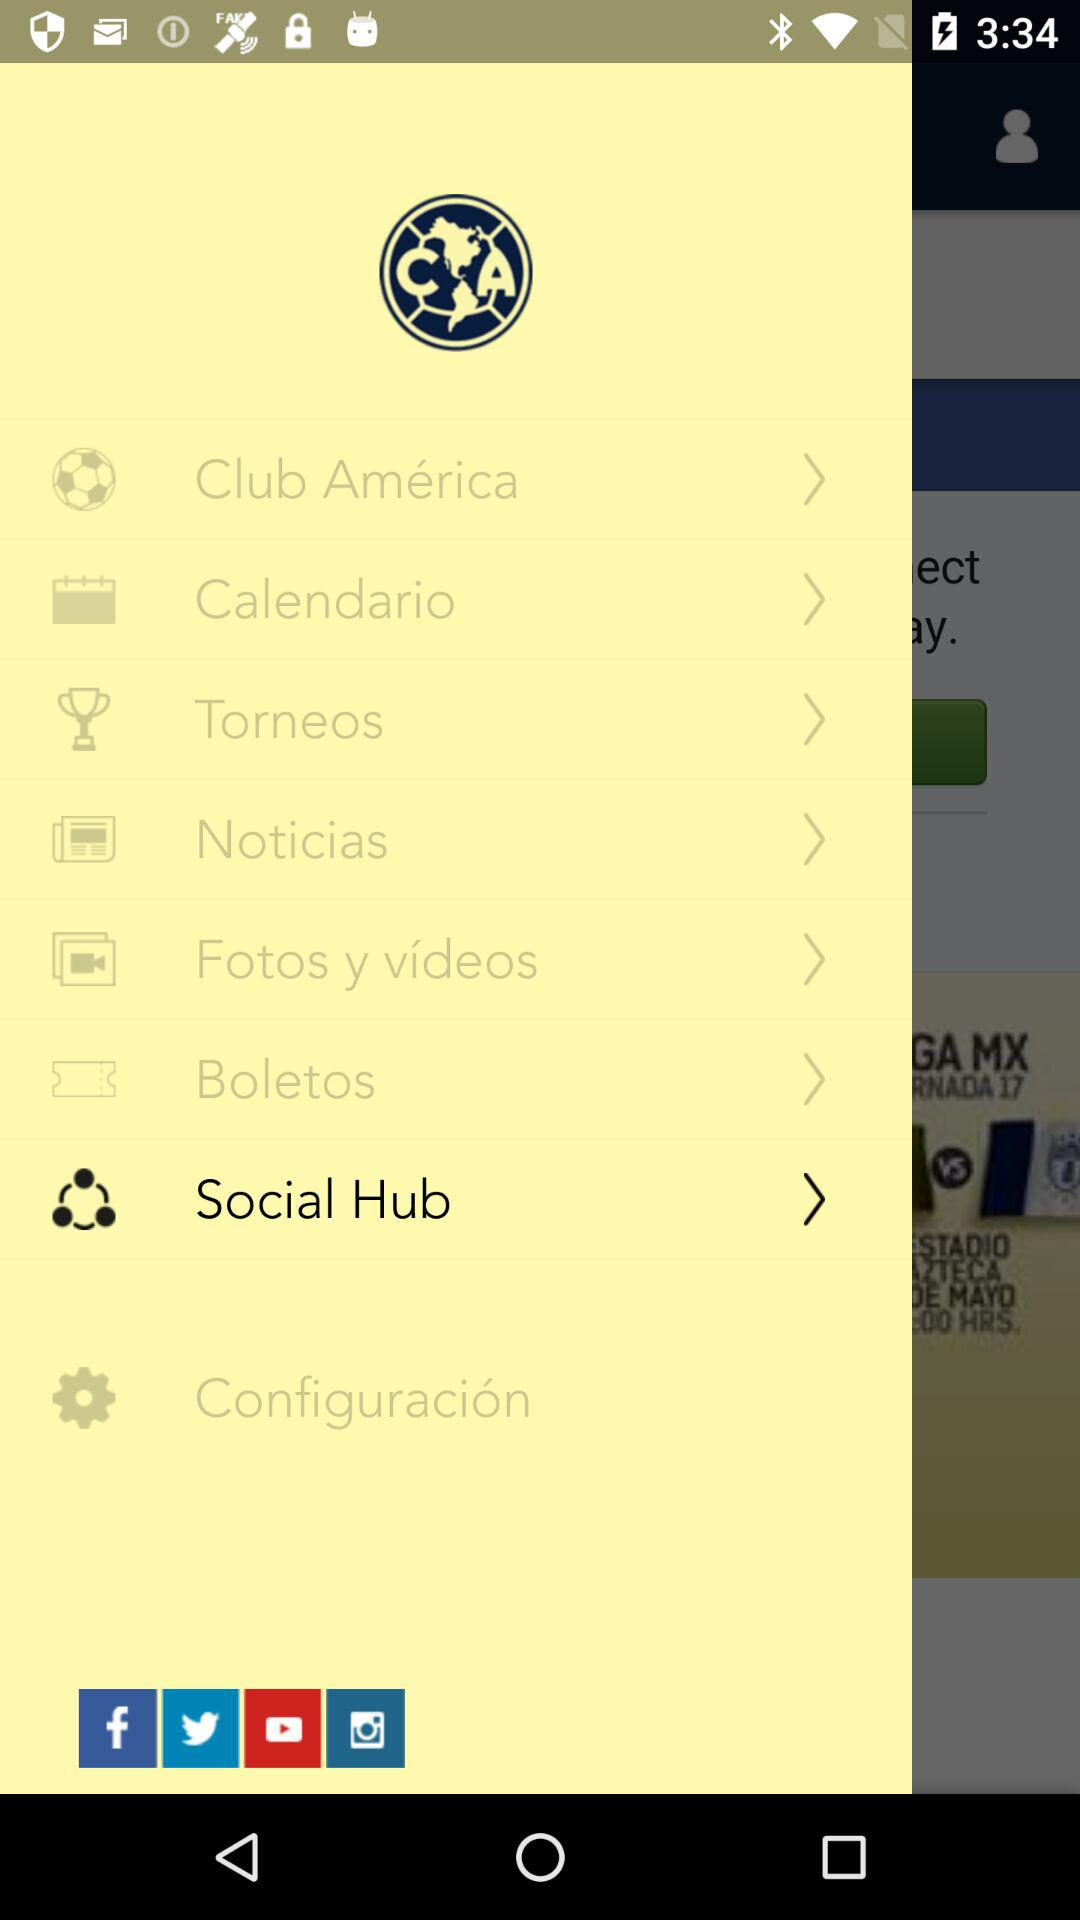How many items are in the main menu?
Answer the question using a single word or phrase. 8 